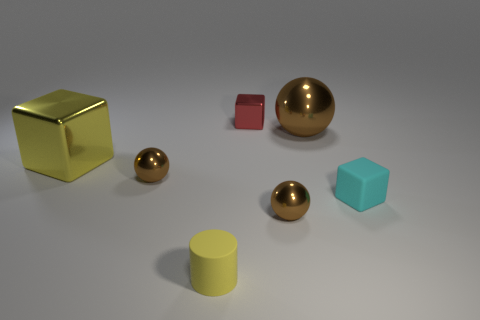Is the size of the brown ball behind the large metallic block the same as the metal block right of the small yellow cylinder?
Give a very brief answer. No. The other object that is made of the same material as the small yellow object is what shape?
Provide a succinct answer. Cube. Is there any other thing that has the same shape as the large yellow metallic object?
Your response must be concise. Yes. What is the color of the small block that is to the left of the tiny metallic sphere that is right of the matte object in front of the cyan object?
Your answer should be very brief. Red. Are there fewer brown objects that are on the right side of the tiny cyan cube than large metal things on the right side of the cylinder?
Your answer should be compact. Yes. Does the large brown object have the same shape as the red metal thing?
Give a very brief answer. No. What number of matte blocks have the same size as the rubber cylinder?
Offer a very short reply. 1. Are there fewer small red blocks on the right side of the small cyan cube than large gray metal cubes?
Make the answer very short. No. How big is the brown ball that is on the left side of the shiny object that is in front of the cyan object?
Your answer should be very brief. Small. What number of things are small things or big spheres?
Make the answer very short. 6. 